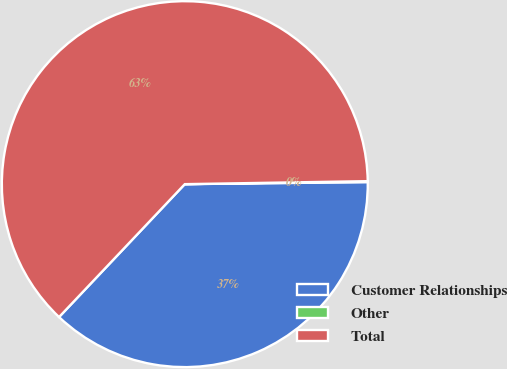Convert chart to OTSL. <chart><loc_0><loc_0><loc_500><loc_500><pie_chart><fcel>Customer Relationships<fcel>Other<fcel>Total<nl><fcel>37.24%<fcel>0.08%<fcel>62.68%<nl></chart> 